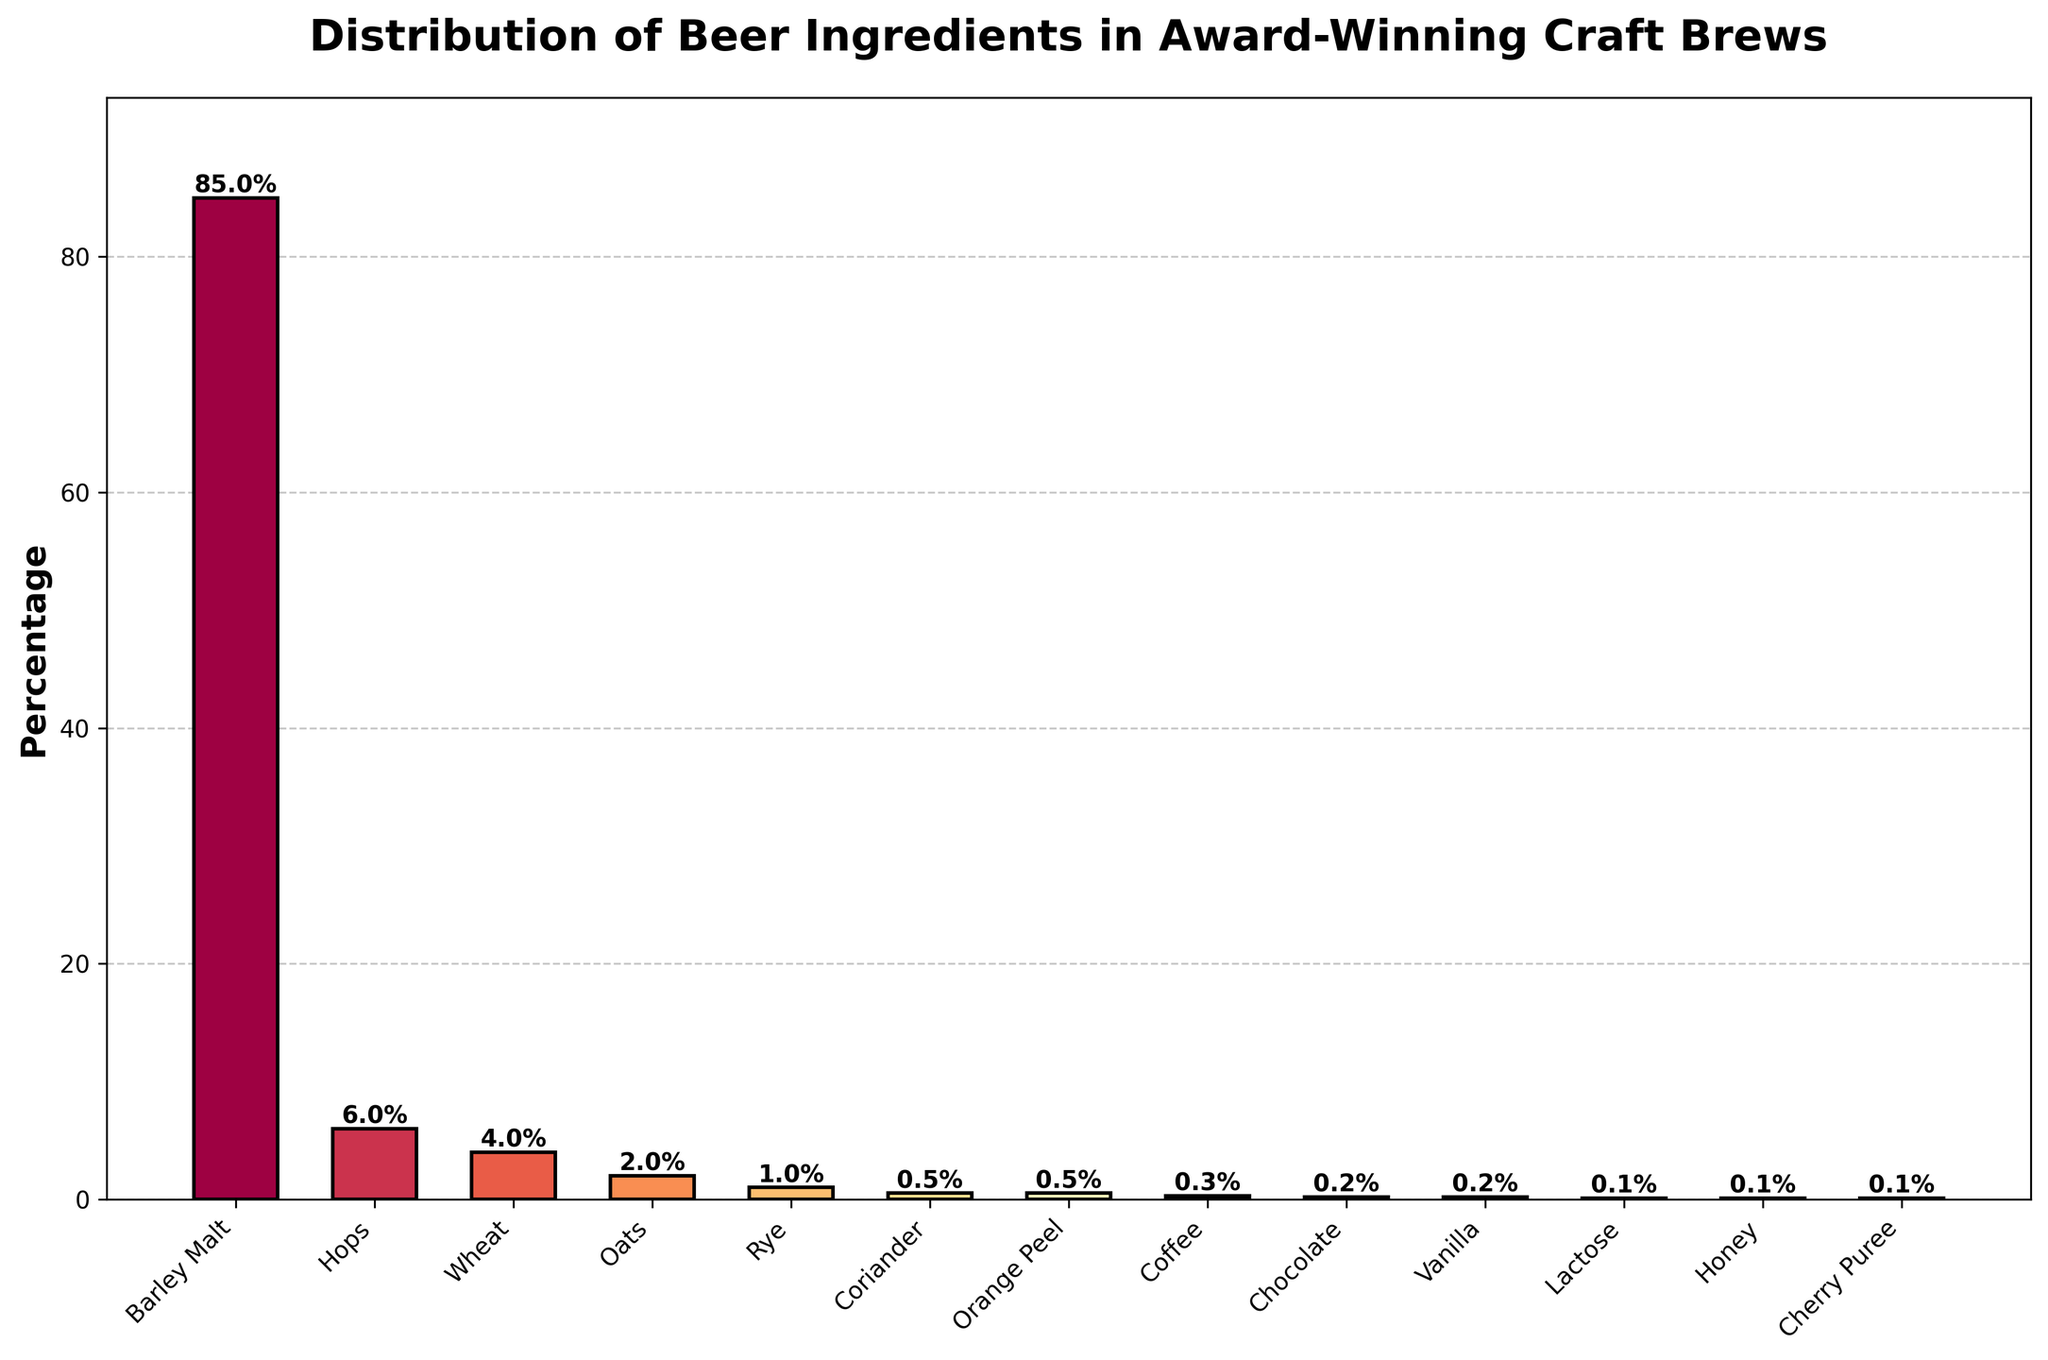What is the most used ingredient in the distribution of beer ingredients? The bar labeled "Barley Malt" is the tallest bar, indicating that Barley Malt is the most used ingredient in the distribution.
Answer: Barley Malt Which ingredient has the lowest percentage in the distribution? The shortest bars represent the ingredients with the lowest percentages. The bars for Lactose, Honey, and Cherry Puree are the smallest, each with a percentage of 0.1%.
Answer: Lactose, Honey, Cherry Puree How much more Barley Malt is used than Hops? The percentage of Barley Malt is 85%, and the percentage of Hops is 6%. The difference is 85% - 6% = 79%.
Answer: 79% Which ingredients have exactly 0.5% each in the distribution? The bars for Coriander and Orange Peel are both marked with exactly 0.5%.
Answer: Coriander, Orange Peel Is the combined percentage of Wheat and Oats greater than the percentage of Hops? Wheat has 4% and Oats has 2%, so their combined percentage is 4% + 2% = 6%. The percentage for Hops is also 6%.
Answer: No What is the combined percentage of the ingredients with a percentage above 1%? Barley Malt (85%), Hops (6%), Wheat (4%), Oats (2%), and Rye (1%) are above 1%. Their combined percentage is 85% + 6% + 4% + 2% + 1% = 98%.
Answer: 98% Which ingredient represents the second highest percentage? The second tallest bar represents Hops with a percentage of 6%.
Answer: Hops How many ingredients have a percentage less than 1%? The bars for Coriander, Orange Peel, Coffee, Chocolate, Vanilla, Lactose, Honey, and Cherry Puree, each of which is less than 1%. There are 8 such ingredients.
Answer: 8 Which two ingredients have the third and fourth largest percentages? The third and fourth tallest bars represent Wheat (4%) and Oats (2%), respectively.
Answer: Wheat, Oats 